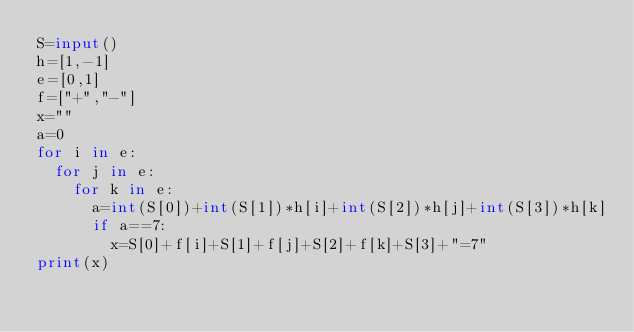<code> <loc_0><loc_0><loc_500><loc_500><_Python_>S=input()
h=[1,-1]
e=[0,1]
f=["+","-"]
x=""
a=0
for i in e:
  for j in e:
    for k in e:
      a=int(S[0])+int(S[1])*h[i]+int(S[2])*h[j]+int(S[3])*h[k]
      if a==7:
        x=S[0]+f[i]+S[1]+f[j]+S[2]+f[k]+S[3]+"=7"
print(x)</code> 